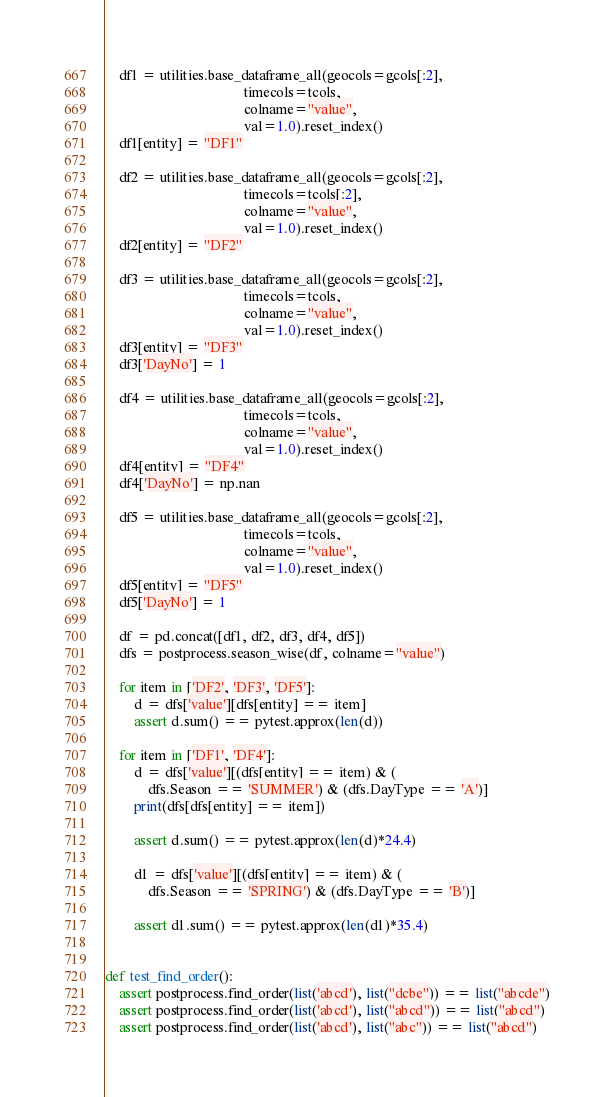<code> <loc_0><loc_0><loc_500><loc_500><_Python_>    df1 = utilities.base_dataframe_all(geocols=gcols[:2],
                                       timecols=tcols,
                                       colname="value",
                                       val=1.0).reset_index()
    df1[entity] = "DF1"

    df2 = utilities.base_dataframe_all(geocols=gcols[:2],
                                       timecols=tcols[:2],
                                       colname="value",
                                       val=1.0).reset_index()
    df2[entity] = "DF2"

    df3 = utilities.base_dataframe_all(geocols=gcols[:2],
                                       timecols=tcols,
                                       colname="value",
                                       val=1.0).reset_index()
    df3[entity] = "DF3"
    df3['DayNo'] = 1

    df4 = utilities.base_dataframe_all(geocols=gcols[:2],
                                       timecols=tcols,
                                       colname="value",
                                       val=1.0).reset_index()
    df4[entity] = "DF4"
    df4['DayNo'] = np.nan

    df5 = utilities.base_dataframe_all(geocols=gcols[:2],
                                       timecols=tcols,
                                       colname="value",
                                       val=1.0).reset_index()
    df5[entity] = "DF5"
    df5['DayNo'] = 1

    df = pd.concat([df1, df2, df3, df4, df5])
    dfs = postprocess.season_wise(df, colname="value")

    for item in ['DF2', 'DF3', 'DF5']:
        d = dfs['value'][dfs[entity] == item]
        assert d.sum() == pytest.approx(len(d))

    for item in ['DF1', 'DF4']:
        d = dfs['value'][(dfs[entity] == item) & (
            dfs.Season == 'SUMMER') & (dfs.DayType == 'A')]
        print(dfs[dfs[entity] == item])

        assert d.sum() == pytest.approx(len(d)*24.4)

        d1 = dfs['value'][(dfs[entity] == item) & (
            dfs.Season == 'SPRING') & (dfs.DayType == 'B')]

        assert d1.sum() == pytest.approx(len(d1)*35.4)


def test_find_order():
    assert postprocess.find_order(list('abcd'), list("dcbe")) == list("abcde")
    assert postprocess.find_order(list('abcd'), list("abcd")) == list("abcd")
    assert postprocess.find_order(list('abcd'), list("abc")) == list("abcd")</code> 